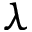<formula> <loc_0><loc_0><loc_500><loc_500>\lambda</formula> 